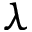<formula> <loc_0><loc_0><loc_500><loc_500>\lambda</formula> 